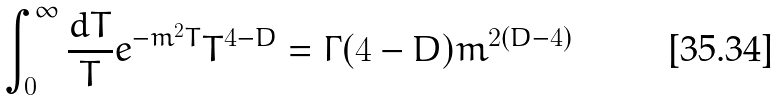<formula> <loc_0><loc_0><loc_500><loc_500>\int _ { 0 } ^ { \infty } \frac { d T } { T } e ^ { - m ^ { 2 } T } T ^ { 4 - D } = \Gamma ( 4 - D ) m ^ { 2 ( D - 4 ) }</formula> 